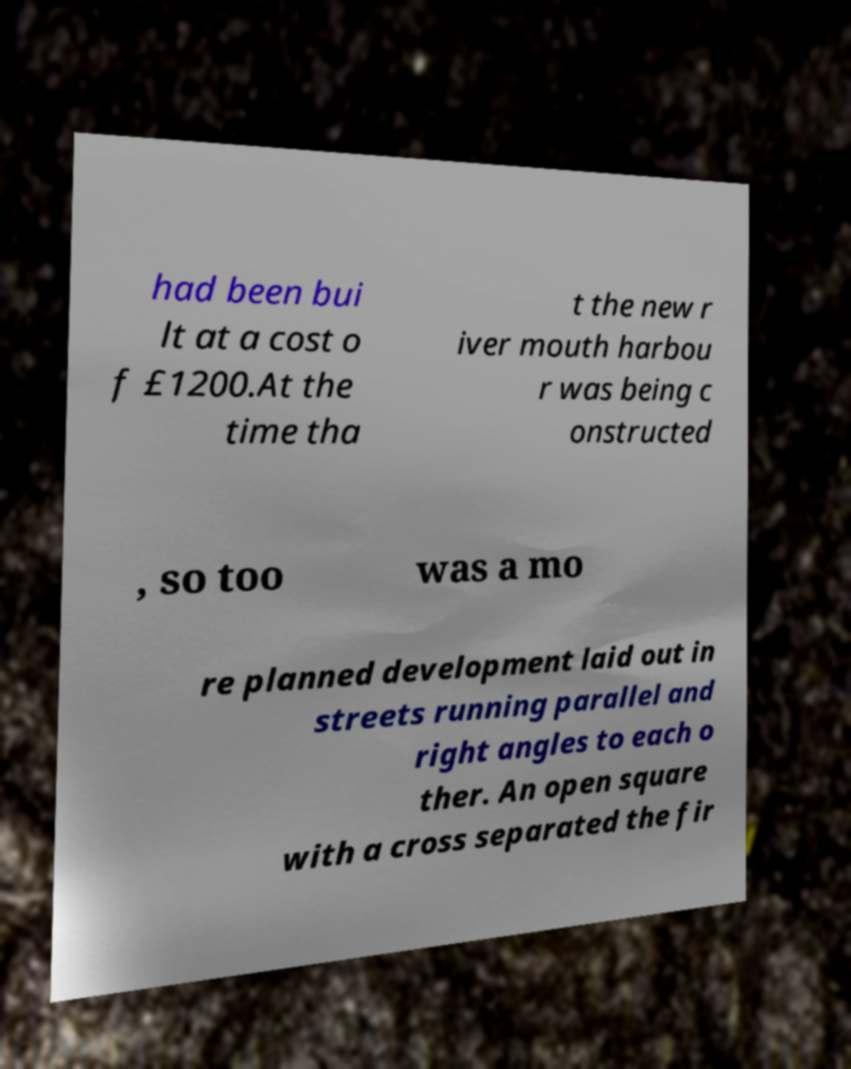I need the written content from this picture converted into text. Can you do that? had been bui lt at a cost o f £1200.At the time tha t the new r iver mouth harbou r was being c onstructed , so too was a mo re planned development laid out in streets running parallel and right angles to each o ther. An open square with a cross separated the fir 